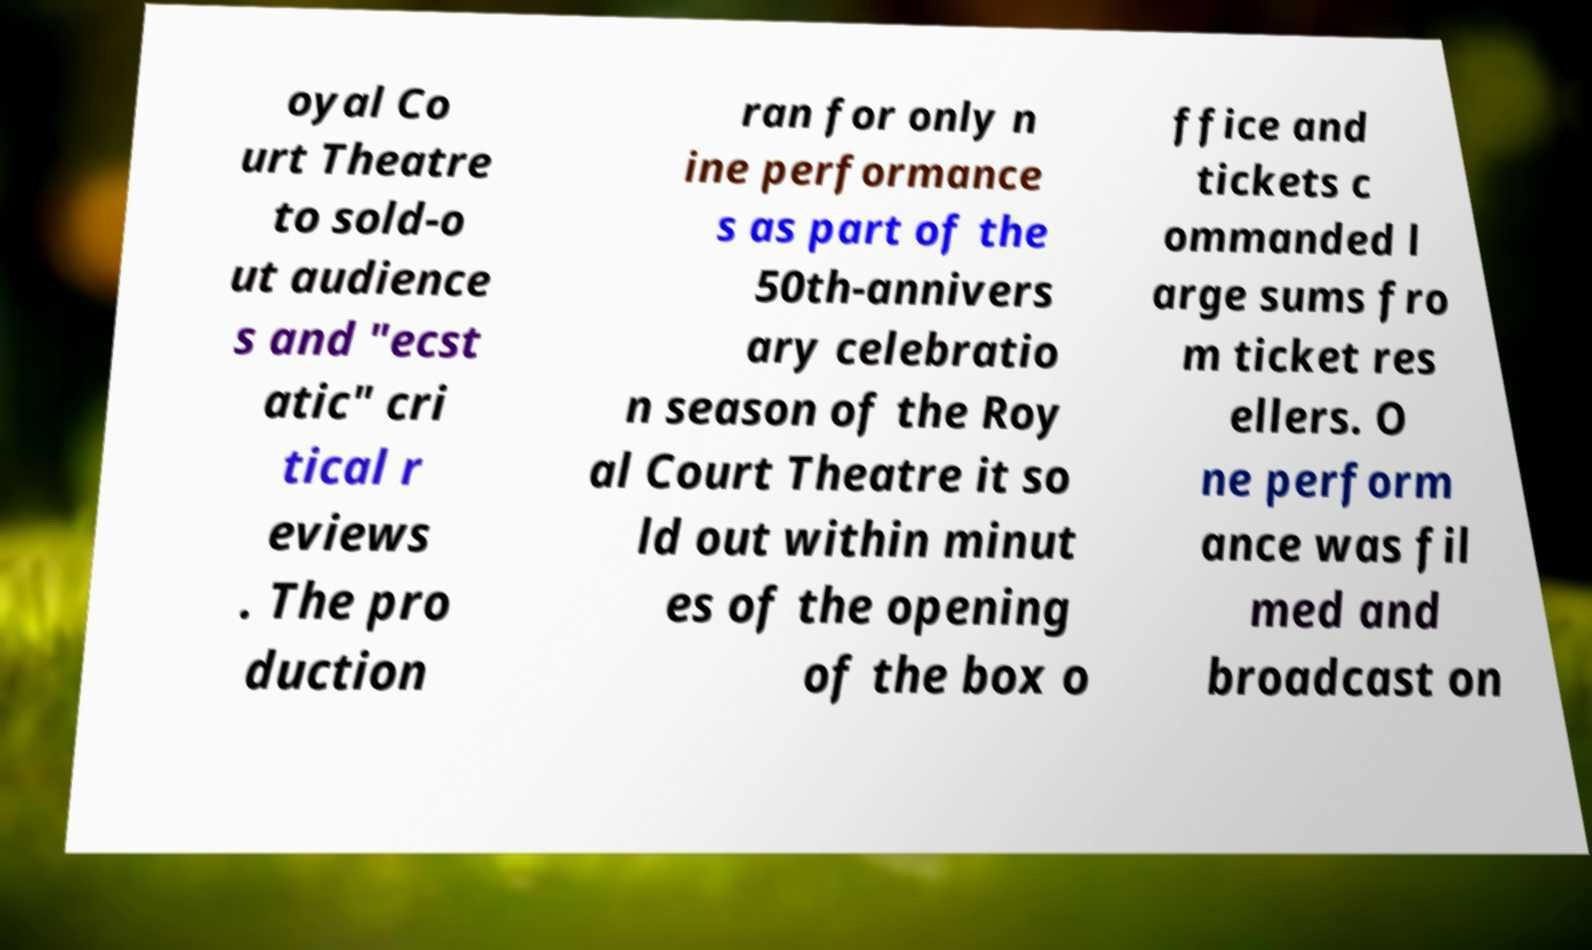For documentation purposes, I need the text within this image transcribed. Could you provide that? oyal Co urt Theatre to sold-o ut audience s and "ecst atic" cri tical r eviews . The pro duction ran for only n ine performance s as part of the 50th-annivers ary celebratio n season of the Roy al Court Theatre it so ld out within minut es of the opening of the box o ffice and tickets c ommanded l arge sums fro m ticket res ellers. O ne perform ance was fil med and broadcast on 